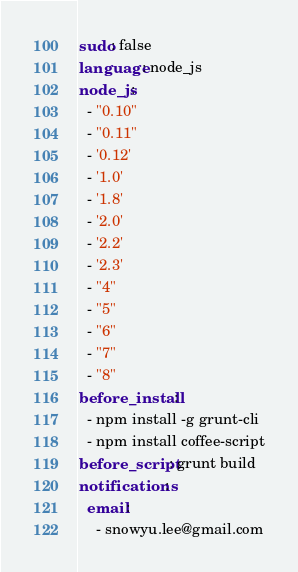<code> <loc_0><loc_0><loc_500><loc_500><_YAML_>sudo: false
language: node_js
node_js:
  - "0.10"
  - "0.11"
  - '0.12'
  - '1.0'
  - '1.8'
  - '2.0'
  - '2.2'
  - '2.3'
  - "4"
  - "5"
  - "6"
  - "7"
  - "8"
before_install:
  - npm install -g grunt-cli
  - npm install coffee-script
before_script: grunt build
notifications:
  email:
    - snowyu.lee@gmail.com

</code> 